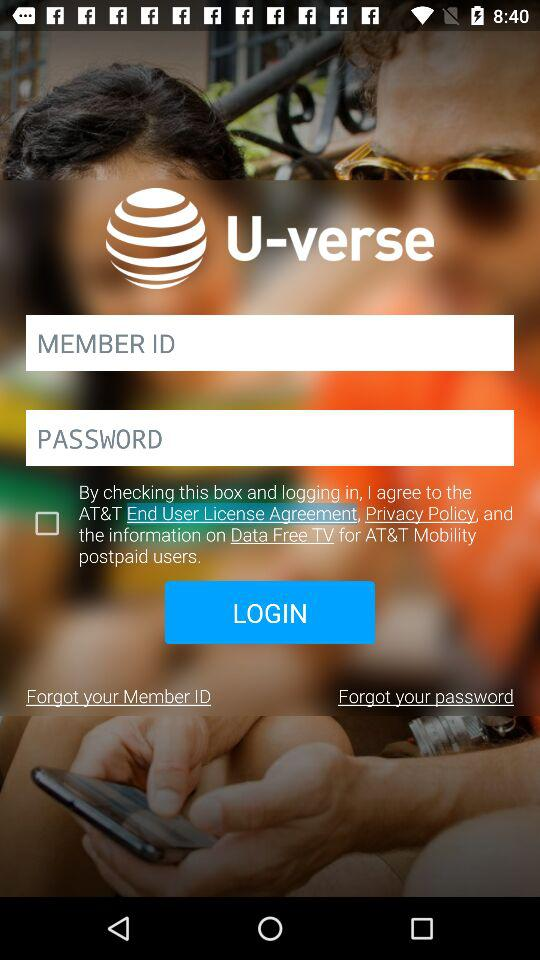What is the application name? The application name is "U-verse". 